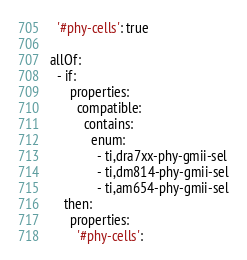Convert code to text. <code><loc_0><loc_0><loc_500><loc_500><_YAML_>
  '#phy-cells': true

allOf:
  - if:
      properties:
        compatible:
          contains:
            enum:
              - ti,dra7xx-phy-gmii-sel
              - ti,dm814-phy-gmii-sel
              - ti,am654-phy-gmii-sel
    then:
      properties:
        '#phy-cells':</code> 